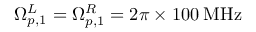Convert formula to latex. <formula><loc_0><loc_0><loc_500><loc_500>\Omega _ { p , 1 } ^ { L } = \Omega _ { p , 1 } ^ { R } = 2 \pi \times 1 0 0 \, M H z</formula> 